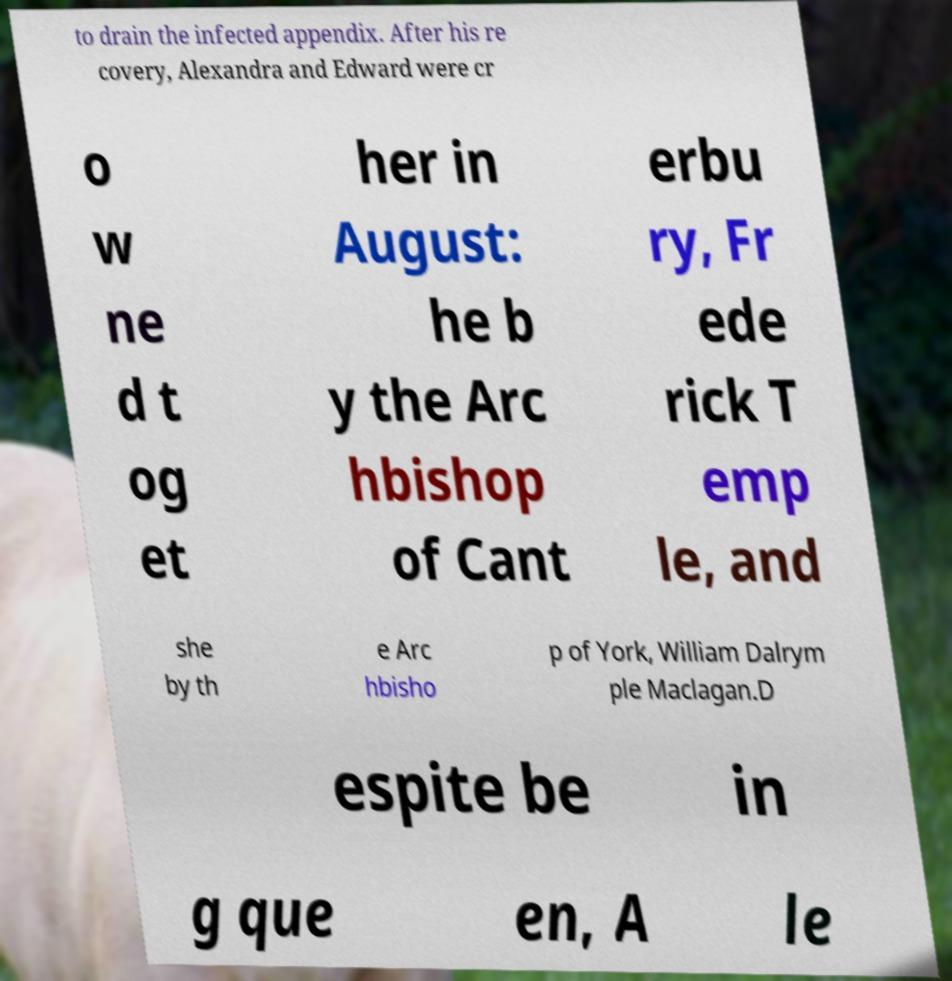Could you extract and type out the text from this image? to drain the infected appendix. After his re covery, Alexandra and Edward were cr o w ne d t og et her in August: he b y the Arc hbishop of Cant erbu ry, Fr ede rick T emp le, and she by th e Arc hbisho p of York, William Dalrym ple Maclagan.D espite be in g que en, A le 